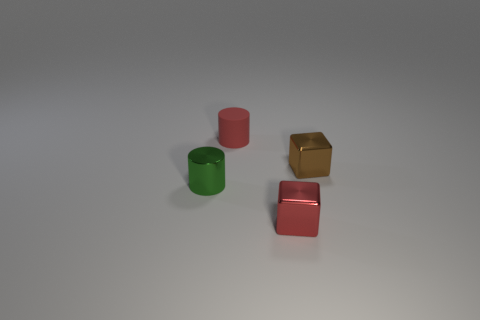Add 1 large brown metal cylinders. How many objects exist? 5 Subtract 2 cylinders. How many cylinders are left? 0 Subtract all cyan blocks. Subtract all red balls. How many blocks are left? 2 Subtract all red balls. How many purple blocks are left? 0 Subtract all tiny brown blocks. Subtract all tiny red objects. How many objects are left? 1 Add 1 small shiny blocks. How many small shiny blocks are left? 3 Add 4 tiny cylinders. How many tiny cylinders exist? 6 Subtract 0 purple cylinders. How many objects are left? 4 